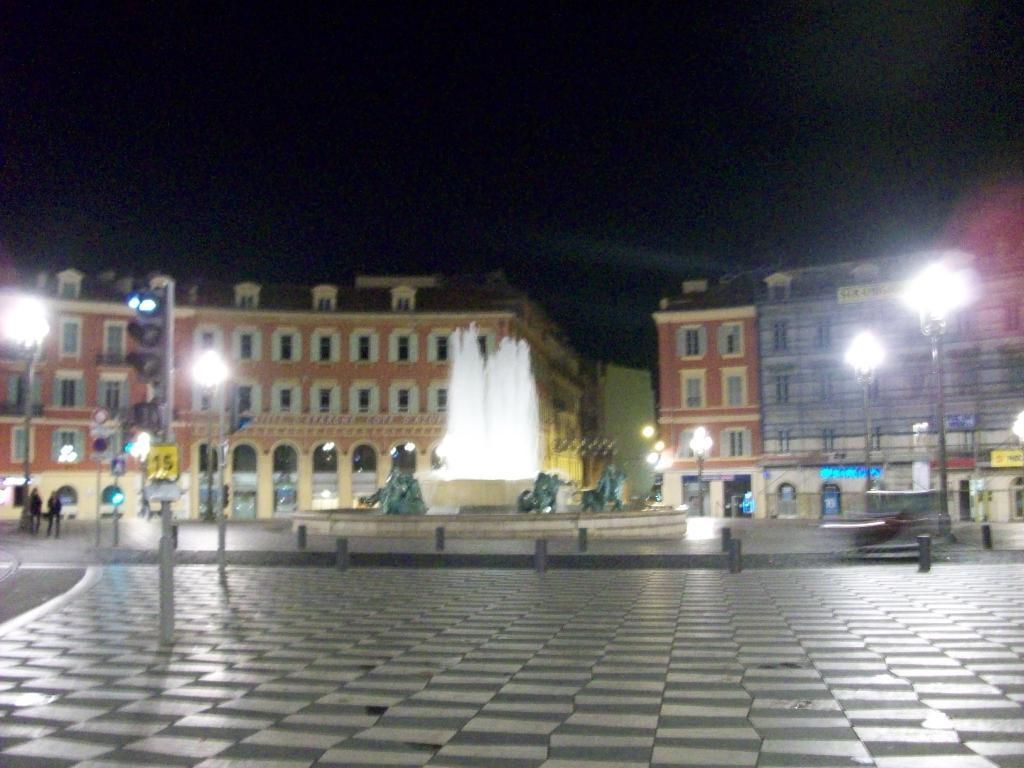What is the main feature in the image? There is a fountain in the image. What can be seen in the distance behind the fountain? There are buildings in the background of the image. Where are the people located in the image? People are standing near a street light pole. Can you see a robin perched on the fountain in the image? There is no robin present in the image. How does the control panel for the fountain look like in the image? The provided facts do not mention a control panel for the fountain, so it cannot be determined from the image. 